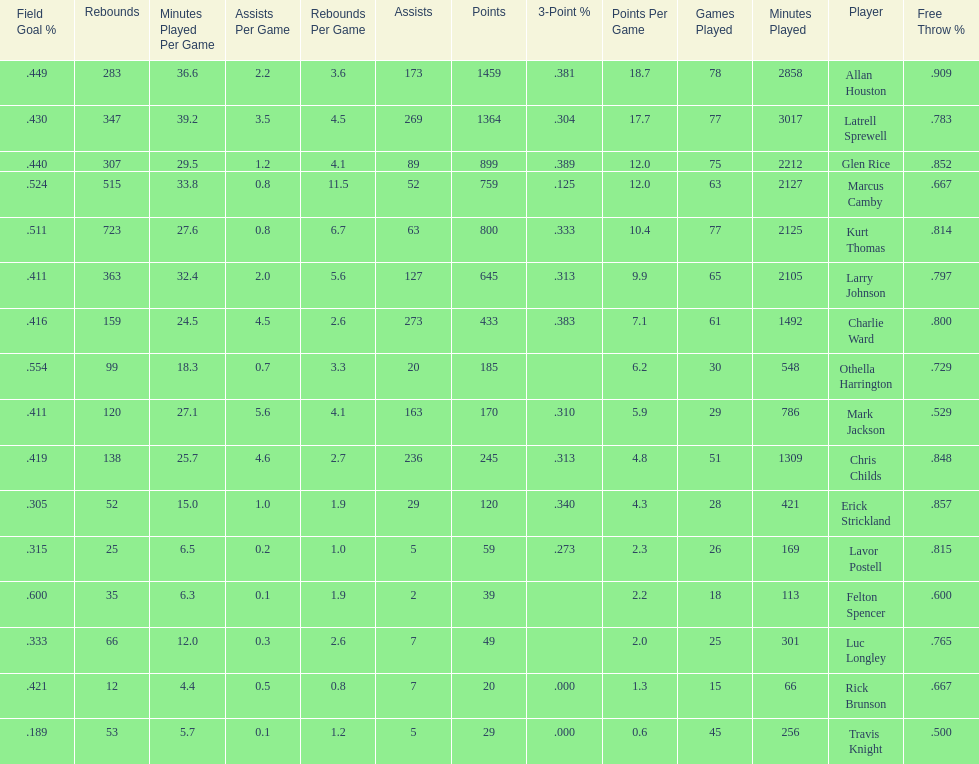How many players had a field goal percentage greater than .500? 4. 